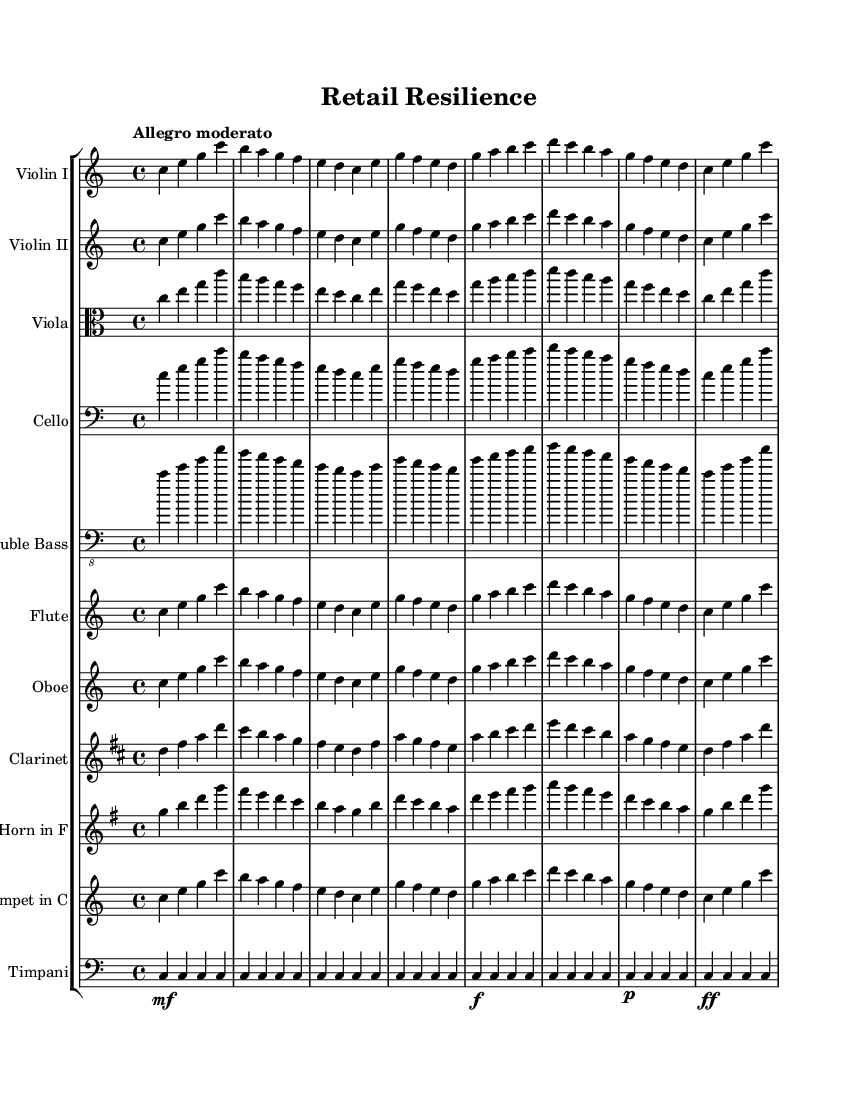What is the key signature of this music? The key signature is indicated at the beginning of the score. It shows no sharps or flats, which defines the piece as being in C major.
Answer: C major What is the time signature of this music? The time signature is found at the beginning of the score, and it indicates a 4/4 time signature, which means there are four beats in each measure, and the quarter note gets one beat.
Answer: 4/4 What is the tempo marking of this music? The tempo marking appears at the start of the piece, where it states "Allegro moderato," indicating a moderately fast pace.
Answer: Allegro moderato Which instrument plays the melody at the beginning? The top staff, labeled "Violin I," typically plays the melody in orchestral music. The part shown there plays the initial melodic phrases.
Answer: Violin I How many different instruments are present in this score? By counting the different staff lines in the score, there are a total of seven distinct instruments including two violins, one viola, one cello, one double bass, one flute, and one oboe, clarinet, and horn.
Answer: Seven What dynamic markings can be found in the Timpani part? The Timpani part contains several dynamic markings, including "mf," "f," "p," and "ff," indicating various levels of loudness throughout the score.
Answer: mf, f, p, ff What transposition is noted for the Clarinet? The clear indication of transposition can be seen where the Clarinet part is written as "transpose bes c'," meaning it is notated a whole step higher than concert pitch.
Answer: B flat 